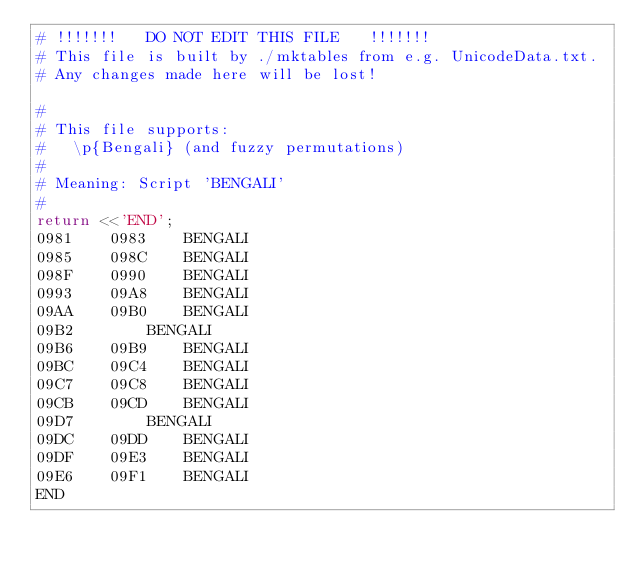<code> <loc_0><loc_0><loc_500><loc_500><_Perl_># !!!!!!!   DO NOT EDIT THIS FILE   !!!!!!! 
# This file is built by ./mktables from e.g. UnicodeData.txt.
# Any changes made here will be lost!

#
# This file supports:
# 	\p{Bengali} (and fuzzy permutations)
# 
# Meaning: Script 'BENGALI'
#
return <<'END';
0981	0983	BENGALI
0985	098C	BENGALI
098F	0990	BENGALI
0993	09A8	BENGALI
09AA	09B0	BENGALI
09B2		BENGALI
09B6	09B9	BENGALI
09BC	09C4	BENGALI
09C7	09C8	BENGALI
09CB	09CD	BENGALI
09D7		BENGALI
09DC	09DD	BENGALI
09DF	09E3	BENGALI
09E6	09F1	BENGALI
END
</code> 